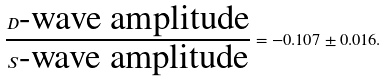Convert formula to latex. <formula><loc_0><loc_0><loc_500><loc_500>\frac { D \text {-wave amplitude} } { S \text {-wave amplitude} } = - 0 . 1 0 7 \pm 0 . 0 1 6 .</formula> 